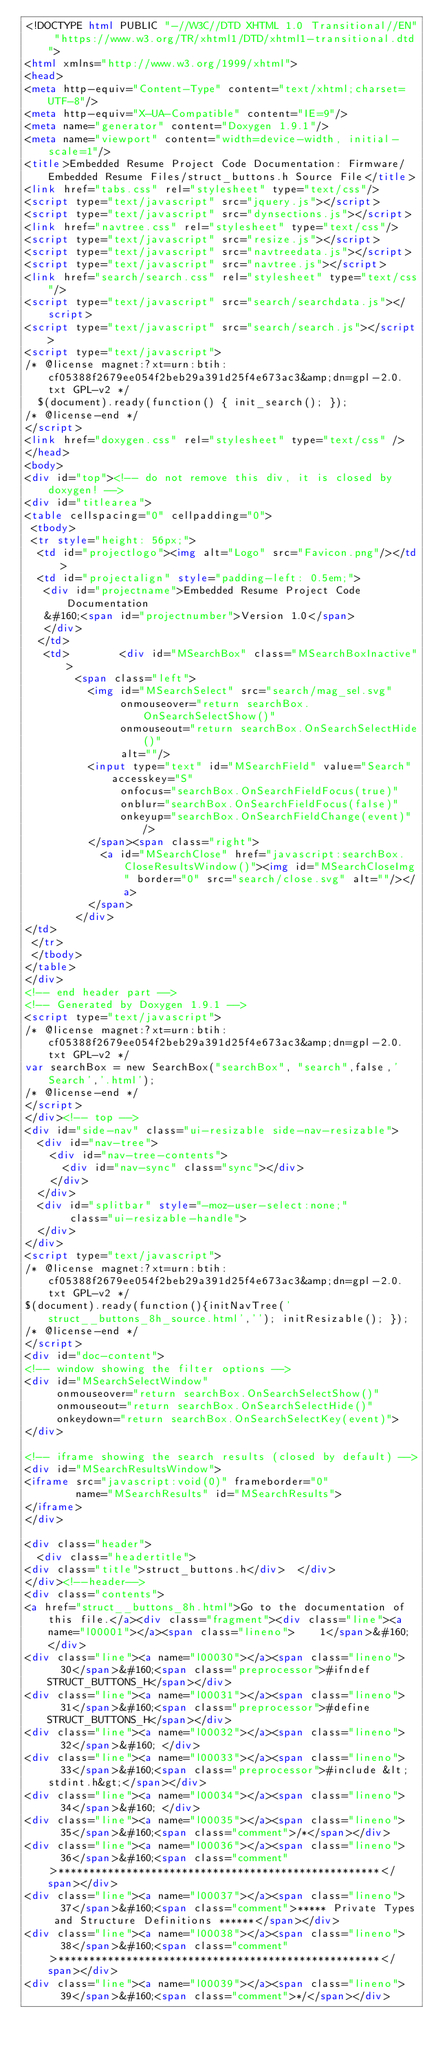Convert code to text. <code><loc_0><loc_0><loc_500><loc_500><_HTML_><!DOCTYPE html PUBLIC "-//W3C//DTD XHTML 1.0 Transitional//EN" "https://www.w3.org/TR/xhtml1/DTD/xhtml1-transitional.dtd">
<html xmlns="http://www.w3.org/1999/xhtml">
<head>
<meta http-equiv="Content-Type" content="text/xhtml;charset=UTF-8"/>
<meta http-equiv="X-UA-Compatible" content="IE=9"/>
<meta name="generator" content="Doxygen 1.9.1"/>
<meta name="viewport" content="width=device-width, initial-scale=1"/>
<title>Embedded Resume Project Code Documentation: Firmware/Embedded Resume Files/struct_buttons.h Source File</title>
<link href="tabs.css" rel="stylesheet" type="text/css"/>
<script type="text/javascript" src="jquery.js"></script>
<script type="text/javascript" src="dynsections.js"></script>
<link href="navtree.css" rel="stylesheet" type="text/css"/>
<script type="text/javascript" src="resize.js"></script>
<script type="text/javascript" src="navtreedata.js"></script>
<script type="text/javascript" src="navtree.js"></script>
<link href="search/search.css" rel="stylesheet" type="text/css"/>
<script type="text/javascript" src="search/searchdata.js"></script>
<script type="text/javascript" src="search/search.js"></script>
<script type="text/javascript">
/* @license magnet:?xt=urn:btih:cf05388f2679ee054f2beb29a391d25f4e673ac3&amp;dn=gpl-2.0.txt GPL-v2 */
  $(document).ready(function() { init_search(); });
/* @license-end */
</script>
<link href="doxygen.css" rel="stylesheet" type="text/css" />
</head>
<body>
<div id="top"><!-- do not remove this div, it is closed by doxygen! -->
<div id="titlearea">
<table cellspacing="0" cellpadding="0">
 <tbody>
 <tr style="height: 56px;">
  <td id="projectlogo"><img alt="Logo" src="Favicon.png"/></td>
  <td id="projectalign" style="padding-left: 0.5em;">
   <div id="projectname">Embedded Resume Project Code Documentation
   &#160;<span id="projectnumber">Version 1.0</span>
   </div>
  </td>
   <td>        <div id="MSearchBox" class="MSearchBoxInactive">
        <span class="left">
          <img id="MSearchSelect" src="search/mag_sel.svg"
               onmouseover="return searchBox.OnSearchSelectShow()"
               onmouseout="return searchBox.OnSearchSelectHide()"
               alt=""/>
          <input type="text" id="MSearchField" value="Search" accesskey="S"
               onfocus="searchBox.OnSearchFieldFocus(true)" 
               onblur="searchBox.OnSearchFieldFocus(false)" 
               onkeyup="searchBox.OnSearchFieldChange(event)"/>
          </span><span class="right">
            <a id="MSearchClose" href="javascript:searchBox.CloseResultsWindow()"><img id="MSearchCloseImg" border="0" src="search/close.svg" alt=""/></a>
          </span>
        </div>
</td>
 </tr>
 </tbody>
</table>
</div>
<!-- end header part -->
<!-- Generated by Doxygen 1.9.1 -->
<script type="text/javascript">
/* @license magnet:?xt=urn:btih:cf05388f2679ee054f2beb29a391d25f4e673ac3&amp;dn=gpl-2.0.txt GPL-v2 */
var searchBox = new SearchBox("searchBox", "search",false,'Search','.html');
/* @license-end */
</script>
</div><!-- top -->
<div id="side-nav" class="ui-resizable side-nav-resizable">
  <div id="nav-tree">
    <div id="nav-tree-contents">
      <div id="nav-sync" class="sync"></div>
    </div>
  </div>
  <div id="splitbar" style="-moz-user-select:none;" 
       class="ui-resizable-handle">
  </div>
</div>
<script type="text/javascript">
/* @license magnet:?xt=urn:btih:cf05388f2679ee054f2beb29a391d25f4e673ac3&amp;dn=gpl-2.0.txt GPL-v2 */
$(document).ready(function(){initNavTree('struct__buttons_8h_source.html',''); initResizable(); });
/* @license-end */
</script>
<div id="doc-content">
<!-- window showing the filter options -->
<div id="MSearchSelectWindow"
     onmouseover="return searchBox.OnSearchSelectShow()"
     onmouseout="return searchBox.OnSearchSelectHide()"
     onkeydown="return searchBox.OnSearchSelectKey(event)">
</div>

<!-- iframe showing the search results (closed by default) -->
<div id="MSearchResultsWindow">
<iframe src="javascript:void(0)" frameborder="0" 
        name="MSearchResults" id="MSearchResults">
</iframe>
</div>

<div class="header">
  <div class="headertitle">
<div class="title">struct_buttons.h</div>  </div>
</div><!--header-->
<div class="contents">
<a href="struct__buttons_8h.html">Go to the documentation of this file.</a><div class="fragment"><div class="line"><a name="l00001"></a><span class="lineno">    1</span>&#160; </div>
<div class="line"><a name="l00030"></a><span class="lineno">   30</span>&#160;<span class="preprocessor">#ifndef STRUCT_BUTTONS_H</span></div>
<div class="line"><a name="l00031"></a><span class="lineno">   31</span>&#160;<span class="preprocessor">#define STRUCT_BUTTONS_H</span></div>
<div class="line"><a name="l00032"></a><span class="lineno">   32</span>&#160; </div>
<div class="line"><a name="l00033"></a><span class="lineno">   33</span>&#160;<span class="preprocessor">#include &lt;stdint.h&gt;</span></div>
<div class="line"><a name="l00034"></a><span class="lineno">   34</span>&#160; </div>
<div class="line"><a name="l00035"></a><span class="lineno">   35</span>&#160;<span class="comment">/*</span></div>
<div class="line"><a name="l00036"></a><span class="lineno">   36</span>&#160;<span class="comment">****************************************************</span></div>
<div class="line"><a name="l00037"></a><span class="lineno">   37</span>&#160;<span class="comment">***** Private Types and Structure Definitions ******</span></div>
<div class="line"><a name="l00038"></a><span class="lineno">   38</span>&#160;<span class="comment">****************************************************</span></div>
<div class="line"><a name="l00039"></a><span class="lineno">   39</span>&#160;<span class="comment">*/</span></div></code> 